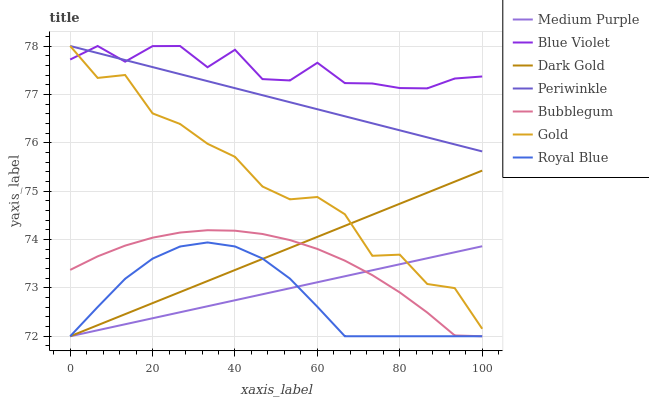Does Royal Blue have the minimum area under the curve?
Answer yes or no. Yes. Does Blue Violet have the maximum area under the curve?
Answer yes or no. Yes. Does Dark Gold have the minimum area under the curve?
Answer yes or no. No. Does Dark Gold have the maximum area under the curve?
Answer yes or no. No. Is Medium Purple the smoothest?
Answer yes or no. Yes. Is Gold the roughest?
Answer yes or no. Yes. Is Dark Gold the smoothest?
Answer yes or no. No. Is Dark Gold the roughest?
Answer yes or no. No. Does Dark Gold have the lowest value?
Answer yes or no. Yes. Does Periwinkle have the lowest value?
Answer yes or no. No. Does Blue Violet have the highest value?
Answer yes or no. Yes. Does Dark Gold have the highest value?
Answer yes or no. No. Is Royal Blue less than Blue Violet?
Answer yes or no. Yes. Is Gold greater than Bubblegum?
Answer yes or no. Yes. Does Dark Gold intersect Medium Purple?
Answer yes or no. Yes. Is Dark Gold less than Medium Purple?
Answer yes or no. No. Is Dark Gold greater than Medium Purple?
Answer yes or no. No. Does Royal Blue intersect Blue Violet?
Answer yes or no. No. 